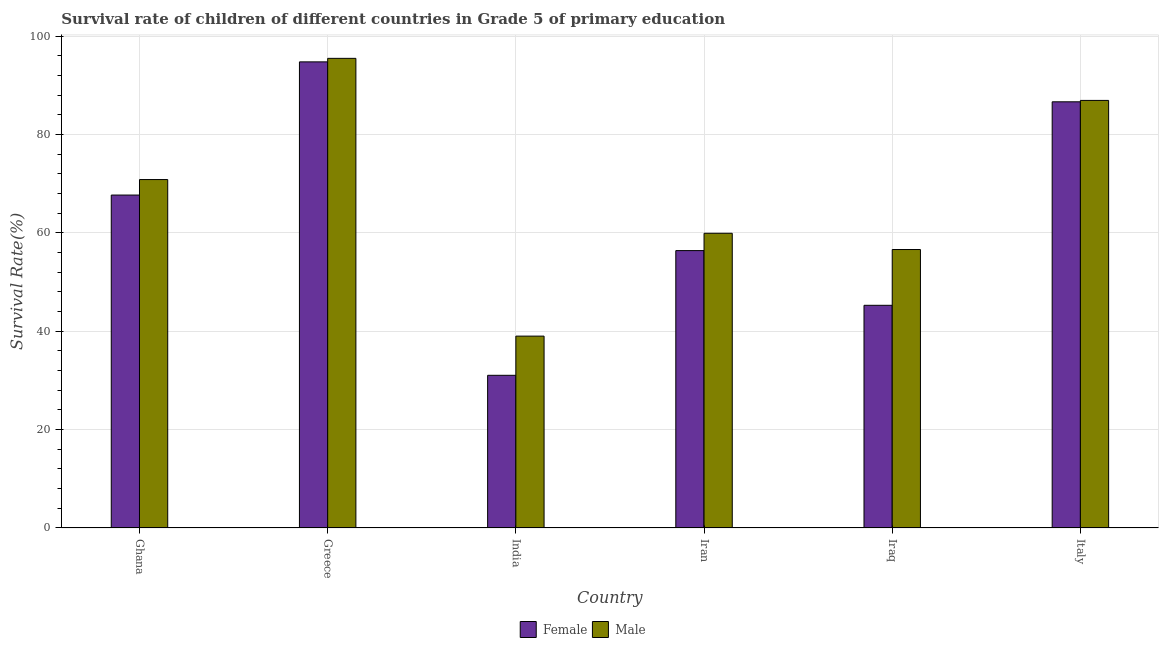How many groups of bars are there?
Provide a succinct answer. 6. Are the number of bars on each tick of the X-axis equal?
Offer a very short reply. Yes. How many bars are there on the 6th tick from the left?
Provide a succinct answer. 2. How many bars are there on the 6th tick from the right?
Your answer should be compact. 2. What is the label of the 4th group of bars from the left?
Your response must be concise. Iran. In how many cases, is the number of bars for a given country not equal to the number of legend labels?
Provide a succinct answer. 0. What is the survival rate of female students in primary education in Iran?
Offer a very short reply. 56.39. Across all countries, what is the maximum survival rate of female students in primary education?
Give a very brief answer. 94.76. Across all countries, what is the minimum survival rate of female students in primary education?
Ensure brevity in your answer.  31.04. In which country was the survival rate of female students in primary education minimum?
Keep it short and to the point. India. What is the total survival rate of male students in primary education in the graph?
Your response must be concise. 408.78. What is the difference between the survival rate of male students in primary education in Ghana and that in India?
Provide a short and direct response. 31.83. What is the difference between the survival rate of female students in primary education in Iraq and the survival rate of male students in primary education in Greece?
Keep it short and to the point. -50.2. What is the average survival rate of female students in primary education per country?
Your response must be concise. 63.63. What is the difference between the survival rate of male students in primary education and survival rate of female students in primary education in Iraq?
Keep it short and to the point. 11.34. In how many countries, is the survival rate of female students in primary education greater than 4 %?
Provide a succinct answer. 6. What is the ratio of the survival rate of female students in primary education in India to that in Iraq?
Make the answer very short. 0.69. What is the difference between the highest and the second highest survival rate of female students in primary education?
Offer a terse response. 8.12. What is the difference between the highest and the lowest survival rate of female students in primary education?
Offer a terse response. 63.72. In how many countries, is the survival rate of male students in primary education greater than the average survival rate of male students in primary education taken over all countries?
Provide a short and direct response. 3. Is the sum of the survival rate of male students in primary education in Ghana and Iraq greater than the maximum survival rate of female students in primary education across all countries?
Give a very brief answer. Yes. What does the 1st bar from the left in Iran represents?
Give a very brief answer. Female. What does the 1st bar from the right in Iraq represents?
Your answer should be very brief. Male. Does the graph contain any zero values?
Offer a very short reply. No. Where does the legend appear in the graph?
Your response must be concise. Bottom center. What is the title of the graph?
Offer a very short reply. Survival rate of children of different countries in Grade 5 of primary education. Does "Register a property" appear as one of the legend labels in the graph?
Provide a succinct answer. No. What is the label or title of the Y-axis?
Offer a terse response. Survival Rate(%). What is the Survival Rate(%) of Female in Ghana?
Your answer should be compact. 67.69. What is the Survival Rate(%) in Male in Ghana?
Your response must be concise. 70.84. What is the Survival Rate(%) in Female in Greece?
Give a very brief answer. 94.76. What is the Survival Rate(%) of Male in Greece?
Keep it short and to the point. 95.48. What is the Survival Rate(%) of Female in India?
Give a very brief answer. 31.04. What is the Survival Rate(%) in Male in India?
Your answer should be compact. 39.01. What is the Survival Rate(%) of Female in Iran?
Your answer should be compact. 56.39. What is the Survival Rate(%) of Male in Iran?
Your response must be concise. 59.92. What is the Survival Rate(%) of Female in Iraq?
Provide a short and direct response. 45.27. What is the Survival Rate(%) of Male in Iraq?
Your response must be concise. 56.61. What is the Survival Rate(%) in Female in Italy?
Keep it short and to the point. 86.64. What is the Survival Rate(%) of Male in Italy?
Keep it short and to the point. 86.93. Across all countries, what is the maximum Survival Rate(%) of Female?
Give a very brief answer. 94.76. Across all countries, what is the maximum Survival Rate(%) of Male?
Offer a very short reply. 95.48. Across all countries, what is the minimum Survival Rate(%) in Female?
Make the answer very short. 31.04. Across all countries, what is the minimum Survival Rate(%) of Male?
Ensure brevity in your answer.  39.01. What is the total Survival Rate(%) of Female in the graph?
Provide a succinct answer. 381.8. What is the total Survival Rate(%) of Male in the graph?
Make the answer very short. 408.78. What is the difference between the Survival Rate(%) of Female in Ghana and that in Greece?
Provide a succinct answer. -27.08. What is the difference between the Survival Rate(%) in Male in Ghana and that in Greece?
Your response must be concise. -24.64. What is the difference between the Survival Rate(%) of Female in Ghana and that in India?
Your response must be concise. 36.65. What is the difference between the Survival Rate(%) of Male in Ghana and that in India?
Your response must be concise. 31.83. What is the difference between the Survival Rate(%) in Female in Ghana and that in Iran?
Your response must be concise. 11.29. What is the difference between the Survival Rate(%) of Male in Ghana and that in Iran?
Give a very brief answer. 10.92. What is the difference between the Survival Rate(%) of Female in Ghana and that in Iraq?
Your response must be concise. 22.41. What is the difference between the Survival Rate(%) in Male in Ghana and that in Iraq?
Your answer should be compact. 14.23. What is the difference between the Survival Rate(%) of Female in Ghana and that in Italy?
Keep it short and to the point. -18.96. What is the difference between the Survival Rate(%) of Male in Ghana and that in Italy?
Make the answer very short. -16.09. What is the difference between the Survival Rate(%) in Female in Greece and that in India?
Keep it short and to the point. 63.72. What is the difference between the Survival Rate(%) in Male in Greece and that in India?
Provide a succinct answer. 56.47. What is the difference between the Survival Rate(%) in Female in Greece and that in Iran?
Your answer should be very brief. 38.37. What is the difference between the Survival Rate(%) of Male in Greece and that in Iran?
Offer a terse response. 35.56. What is the difference between the Survival Rate(%) of Female in Greece and that in Iraq?
Offer a very short reply. 49.49. What is the difference between the Survival Rate(%) of Male in Greece and that in Iraq?
Offer a very short reply. 38.86. What is the difference between the Survival Rate(%) of Female in Greece and that in Italy?
Your response must be concise. 8.12. What is the difference between the Survival Rate(%) of Male in Greece and that in Italy?
Provide a short and direct response. 8.55. What is the difference between the Survival Rate(%) in Female in India and that in Iran?
Offer a very short reply. -25.35. What is the difference between the Survival Rate(%) in Male in India and that in Iran?
Give a very brief answer. -20.91. What is the difference between the Survival Rate(%) in Female in India and that in Iraq?
Offer a terse response. -14.23. What is the difference between the Survival Rate(%) in Male in India and that in Iraq?
Ensure brevity in your answer.  -17.6. What is the difference between the Survival Rate(%) of Female in India and that in Italy?
Your answer should be very brief. -55.6. What is the difference between the Survival Rate(%) in Male in India and that in Italy?
Keep it short and to the point. -47.92. What is the difference between the Survival Rate(%) of Female in Iran and that in Iraq?
Your response must be concise. 11.12. What is the difference between the Survival Rate(%) of Male in Iran and that in Iraq?
Your answer should be compact. 3.3. What is the difference between the Survival Rate(%) in Female in Iran and that in Italy?
Your answer should be very brief. -30.25. What is the difference between the Survival Rate(%) of Male in Iran and that in Italy?
Provide a short and direct response. -27.01. What is the difference between the Survival Rate(%) of Female in Iraq and that in Italy?
Offer a very short reply. -41.37. What is the difference between the Survival Rate(%) of Male in Iraq and that in Italy?
Give a very brief answer. -30.32. What is the difference between the Survival Rate(%) in Female in Ghana and the Survival Rate(%) in Male in Greece?
Ensure brevity in your answer.  -27.79. What is the difference between the Survival Rate(%) in Female in Ghana and the Survival Rate(%) in Male in India?
Keep it short and to the point. 28.68. What is the difference between the Survival Rate(%) in Female in Ghana and the Survival Rate(%) in Male in Iran?
Your response must be concise. 7.77. What is the difference between the Survival Rate(%) in Female in Ghana and the Survival Rate(%) in Male in Iraq?
Offer a terse response. 11.07. What is the difference between the Survival Rate(%) in Female in Ghana and the Survival Rate(%) in Male in Italy?
Keep it short and to the point. -19.24. What is the difference between the Survival Rate(%) in Female in Greece and the Survival Rate(%) in Male in India?
Provide a short and direct response. 55.75. What is the difference between the Survival Rate(%) in Female in Greece and the Survival Rate(%) in Male in Iran?
Offer a very short reply. 34.85. What is the difference between the Survival Rate(%) of Female in Greece and the Survival Rate(%) of Male in Iraq?
Offer a very short reply. 38.15. What is the difference between the Survival Rate(%) in Female in Greece and the Survival Rate(%) in Male in Italy?
Offer a terse response. 7.83. What is the difference between the Survival Rate(%) in Female in India and the Survival Rate(%) in Male in Iran?
Your answer should be compact. -28.88. What is the difference between the Survival Rate(%) of Female in India and the Survival Rate(%) of Male in Iraq?
Your response must be concise. -25.57. What is the difference between the Survival Rate(%) in Female in India and the Survival Rate(%) in Male in Italy?
Offer a very short reply. -55.89. What is the difference between the Survival Rate(%) of Female in Iran and the Survival Rate(%) of Male in Iraq?
Your response must be concise. -0.22. What is the difference between the Survival Rate(%) in Female in Iran and the Survival Rate(%) in Male in Italy?
Your response must be concise. -30.53. What is the difference between the Survival Rate(%) in Female in Iraq and the Survival Rate(%) in Male in Italy?
Offer a terse response. -41.65. What is the average Survival Rate(%) in Female per country?
Give a very brief answer. 63.63. What is the average Survival Rate(%) in Male per country?
Offer a terse response. 68.13. What is the difference between the Survival Rate(%) of Female and Survival Rate(%) of Male in Ghana?
Give a very brief answer. -3.15. What is the difference between the Survival Rate(%) of Female and Survival Rate(%) of Male in Greece?
Provide a succinct answer. -0.72. What is the difference between the Survival Rate(%) of Female and Survival Rate(%) of Male in India?
Your answer should be compact. -7.97. What is the difference between the Survival Rate(%) in Female and Survival Rate(%) in Male in Iran?
Give a very brief answer. -3.52. What is the difference between the Survival Rate(%) in Female and Survival Rate(%) in Male in Iraq?
Your answer should be compact. -11.34. What is the difference between the Survival Rate(%) of Female and Survival Rate(%) of Male in Italy?
Keep it short and to the point. -0.29. What is the ratio of the Survival Rate(%) of Female in Ghana to that in Greece?
Keep it short and to the point. 0.71. What is the ratio of the Survival Rate(%) of Male in Ghana to that in Greece?
Offer a terse response. 0.74. What is the ratio of the Survival Rate(%) of Female in Ghana to that in India?
Provide a short and direct response. 2.18. What is the ratio of the Survival Rate(%) in Male in Ghana to that in India?
Offer a terse response. 1.82. What is the ratio of the Survival Rate(%) in Female in Ghana to that in Iran?
Your answer should be compact. 1.2. What is the ratio of the Survival Rate(%) of Male in Ghana to that in Iran?
Your response must be concise. 1.18. What is the ratio of the Survival Rate(%) in Female in Ghana to that in Iraq?
Make the answer very short. 1.5. What is the ratio of the Survival Rate(%) in Male in Ghana to that in Iraq?
Give a very brief answer. 1.25. What is the ratio of the Survival Rate(%) of Female in Ghana to that in Italy?
Keep it short and to the point. 0.78. What is the ratio of the Survival Rate(%) of Male in Ghana to that in Italy?
Offer a terse response. 0.81. What is the ratio of the Survival Rate(%) of Female in Greece to that in India?
Provide a short and direct response. 3.05. What is the ratio of the Survival Rate(%) of Male in Greece to that in India?
Offer a very short reply. 2.45. What is the ratio of the Survival Rate(%) of Female in Greece to that in Iran?
Ensure brevity in your answer.  1.68. What is the ratio of the Survival Rate(%) in Male in Greece to that in Iran?
Ensure brevity in your answer.  1.59. What is the ratio of the Survival Rate(%) of Female in Greece to that in Iraq?
Make the answer very short. 2.09. What is the ratio of the Survival Rate(%) in Male in Greece to that in Iraq?
Offer a very short reply. 1.69. What is the ratio of the Survival Rate(%) in Female in Greece to that in Italy?
Your response must be concise. 1.09. What is the ratio of the Survival Rate(%) of Male in Greece to that in Italy?
Make the answer very short. 1.1. What is the ratio of the Survival Rate(%) in Female in India to that in Iran?
Keep it short and to the point. 0.55. What is the ratio of the Survival Rate(%) in Male in India to that in Iran?
Give a very brief answer. 0.65. What is the ratio of the Survival Rate(%) of Female in India to that in Iraq?
Provide a succinct answer. 0.69. What is the ratio of the Survival Rate(%) in Male in India to that in Iraq?
Offer a very short reply. 0.69. What is the ratio of the Survival Rate(%) in Female in India to that in Italy?
Make the answer very short. 0.36. What is the ratio of the Survival Rate(%) of Male in India to that in Italy?
Give a very brief answer. 0.45. What is the ratio of the Survival Rate(%) of Female in Iran to that in Iraq?
Your answer should be compact. 1.25. What is the ratio of the Survival Rate(%) in Male in Iran to that in Iraq?
Ensure brevity in your answer.  1.06. What is the ratio of the Survival Rate(%) of Female in Iran to that in Italy?
Make the answer very short. 0.65. What is the ratio of the Survival Rate(%) in Male in Iran to that in Italy?
Your answer should be very brief. 0.69. What is the ratio of the Survival Rate(%) in Female in Iraq to that in Italy?
Keep it short and to the point. 0.52. What is the ratio of the Survival Rate(%) of Male in Iraq to that in Italy?
Offer a terse response. 0.65. What is the difference between the highest and the second highest Survival Rate(%) of Female?
Provide a short and direct response. 8.12. What is the difference between the highest and the second highest Survival Rate(%) in Male?
Keep it short and to the point. 8.55. What is the difference between the highest and the lowest Survival Rate(%) of Female?
Make the answer very short. 63.72. What is the difference between the highest and the lowest Survival Rate(%) in Male?
Keep it short and to the point. 56.47. 